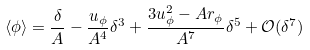Convert formula to latex. <formula><loc_0><loc_0><loc_500><loc_500>\langle \phi \rangle = \frac { \delta } { A } - \frac { u _ { \phi } } { A ^ { 4 } } \delta ^ { 3 } + \frac { 3 u _ { \phi } ^ { 2 } - A r _ { \phi } } { A ^ { 7 } } \delta ^ { 5 } + \mathcal { O } ( \delta ^ { 7 } )</formula> 